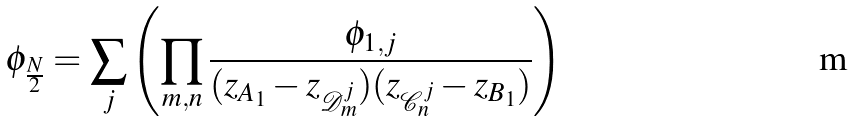<formula> <loc_0><loc_0><loc_500><loc_500>\phi _ { \frac { N } { 2 } } = \sum _ { j } \left ( \prod _ { m , n } \frac { \phi _ { 1 , j } } { ( z _ { A _ { 1 } } - z _ { \mathcal { D } ^ { j } _ { m } } ) ( z _ { \mathcal { C } ^ { j } _ { n } } - z _ { B _ { 1 } } ) } \right )</formula> 